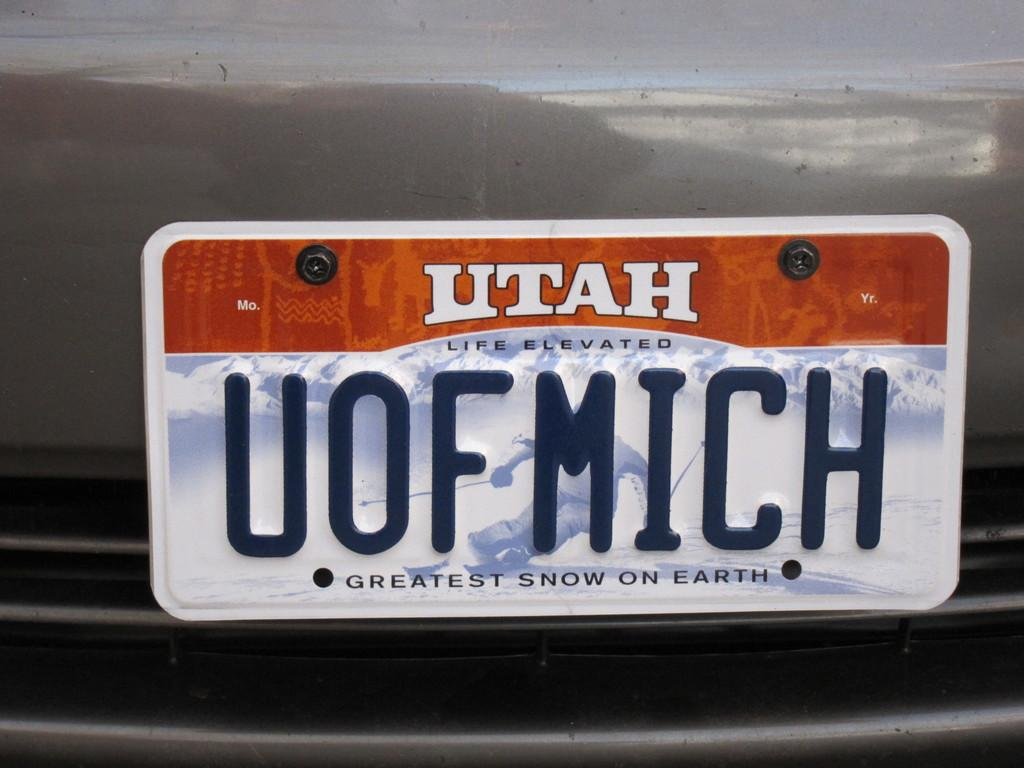<image>
Provide a brief description of the given image. A Utah vehicle with a personalized University of Michigan license plate. 